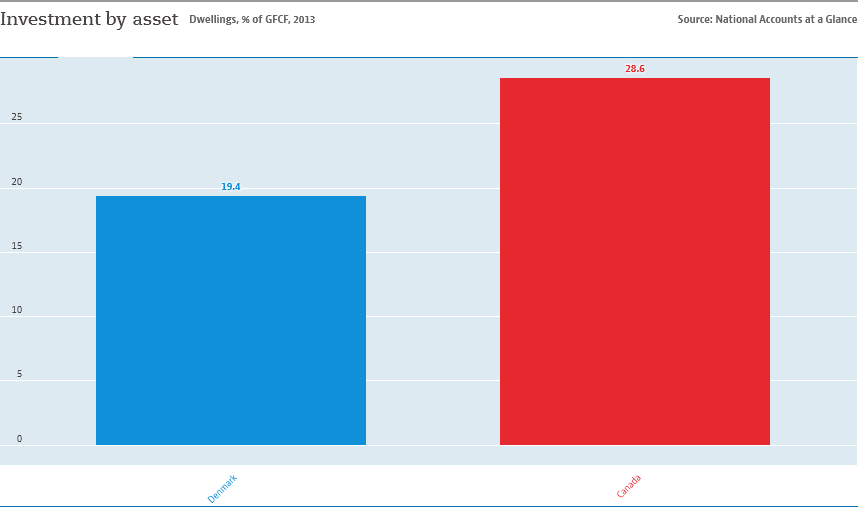Give some essential details in this illustration. Denmark is not equal to twice the value of Canada. The red bar represents Canada. 